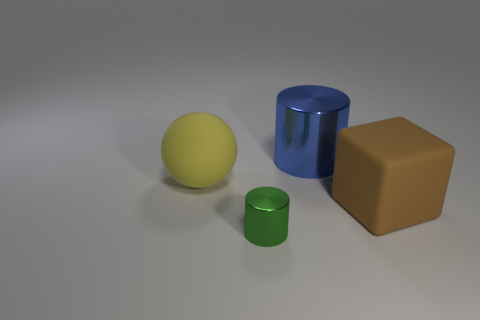Are there any other things that are the same size as the green shiny thing?
Provide a succinct answer. No. What is the shape of the object that is both in front of the yellow ball and to the right of the green thing?
Keep it short and to the point. Cube. What is the shape of the rubber object that is to the left of the shiny cylinder that is in front of the large matte sphere?
Ensure brevity in your answer.  Sphere. Does the blue thing have the same shape as the big yellow thing?
Make the answer very short. No. Does the tiny metal cylinder have the same color as the large block?
Your response must be concise. No. What number of yellow balls are left of the large rubber object on the right side of the rubber thing to the left of the big blue metallic cylinder?
Your answer should be very brief. 1. There is a yellow object that is the same material as the cube; what is its shape?
Ensure brevity in your answer.  Sphere. There is a large object left of the metal thing to the left of the metal cylinder behind the green metal object; what is it made of?
Offer a very short reply. Rubber. How many things are big metal cylinders that are right of the yellow sphere or big yellow matte spheres?
Give a very brief answer. 2. How many other things are there of the same shape as the yellow thing?
Ensure brevity in your answer.  0. 